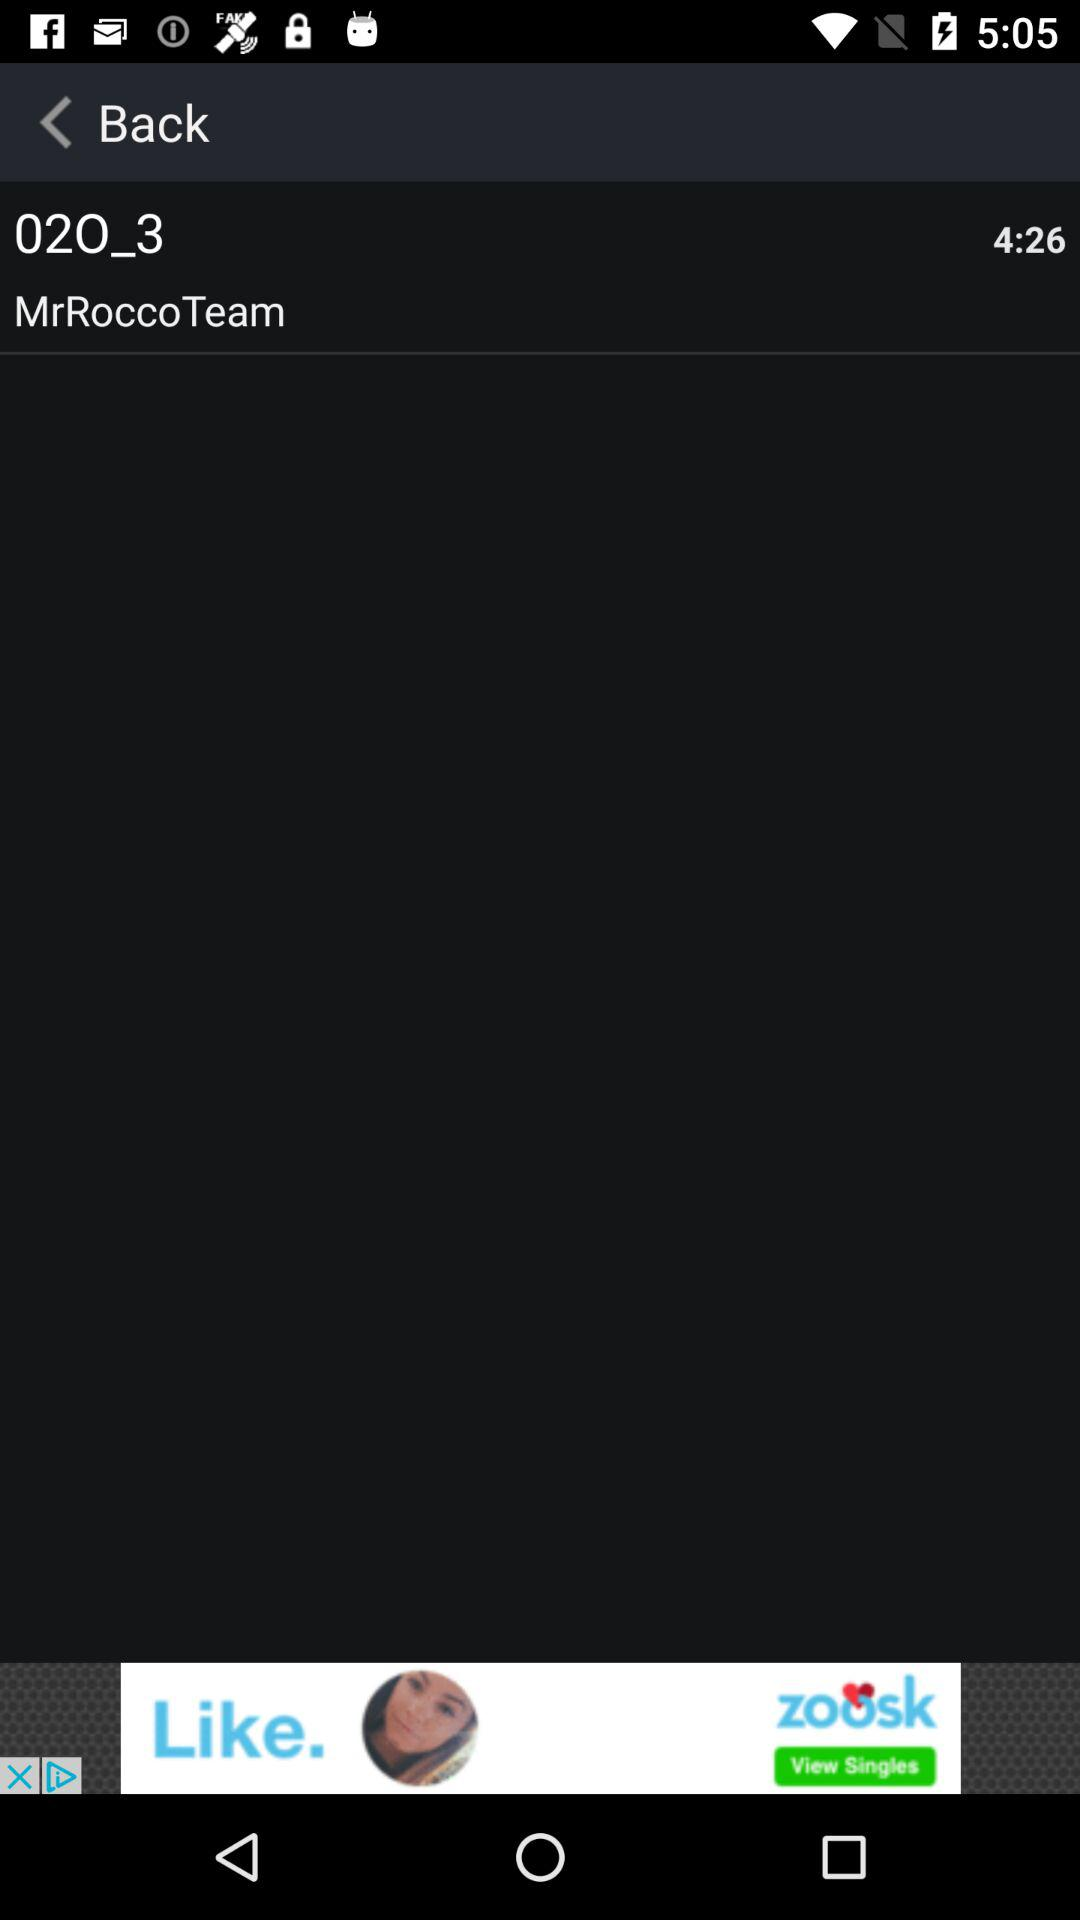What is the total duration? The total duration is 4 minutes 26 seconds. 